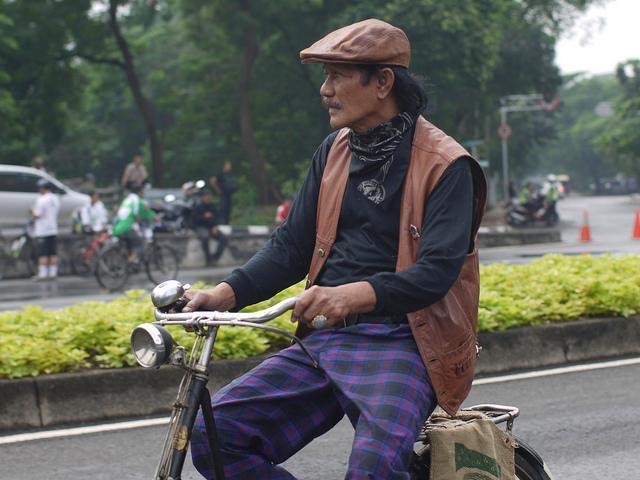How many bicycles are there?
Give a very brief answer. 2. How many people are there?
Give a very brief answer. 3. 